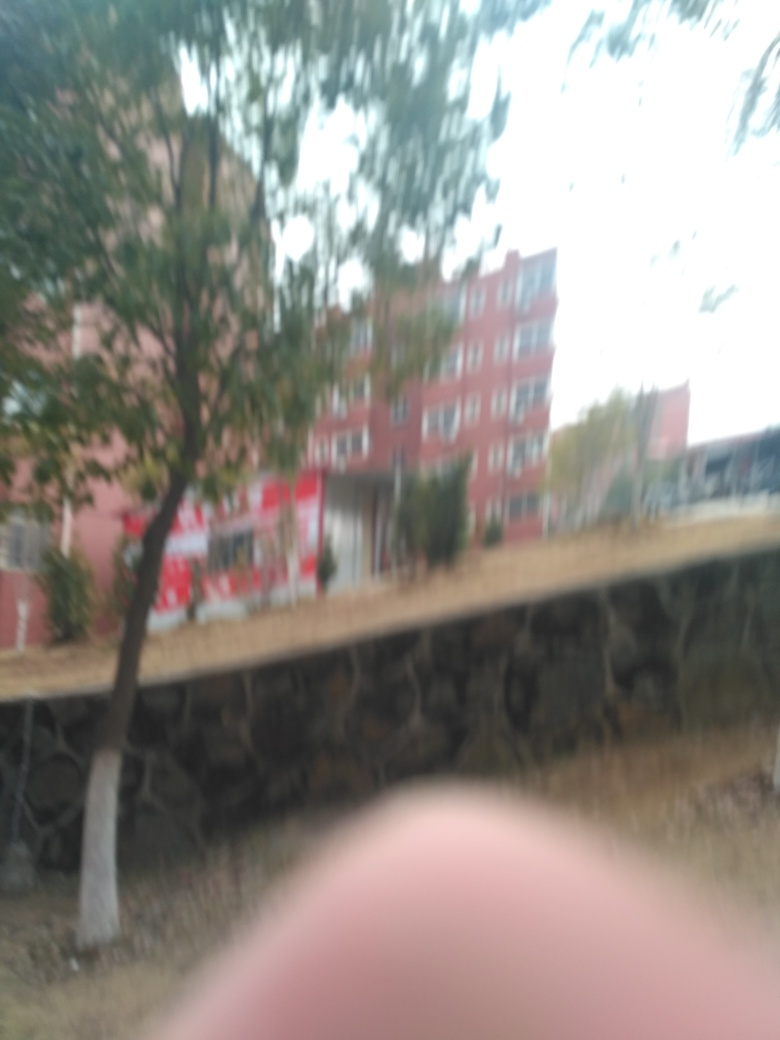If this image were part of a story, what context or events do you imagine could be depicted? If this image were part of a story, it could represent a moment of haste or confusion in the plot, possibly depicting the protagonist's hurried escape or chase scene, where the blurriness conveys a sense of urgency and disorientation. 